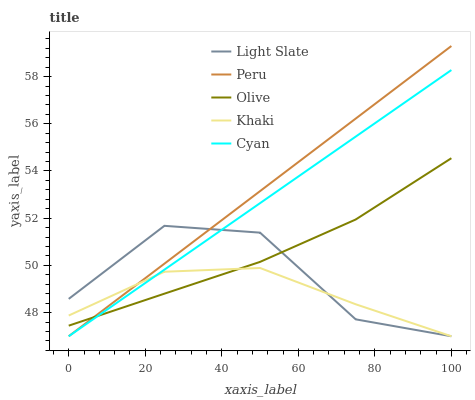Does Khaki have the minimum area under the curve?
Answer yes or no. Yes. Does Peru have the maximum area under the curve?
Answer yes or no. Yes. Does Olive have the minimum area under the curve?
Answer yes or no. No. Does Olive have the maximum area under the curve?
Answer yes or no. No. Is Peru the smoothest?
Answer yes or no. Yes. Is Light Slate the roughest?
Answer yes or no. Yes. Is Olive the smoothest?
Answer yes or no. No. Is Olive the roughest?
Answer yes or no. No. Does Light Slate have the lowest value?
Answer yes or no. Yes. Does Olive have the lowest value?
Answer yes or no. No. Does Peru have the highest value?
Answer yes or no. Yes. Does Olive have the highest value?
Answer yes or no. No. Does Cyan intersect Khaki?
Answer yes or no. Yes. Is Cyan less than Khaki?
Answer yes or no. No. Is Cyan greater than Khaki?
Answer yes or no. No. 